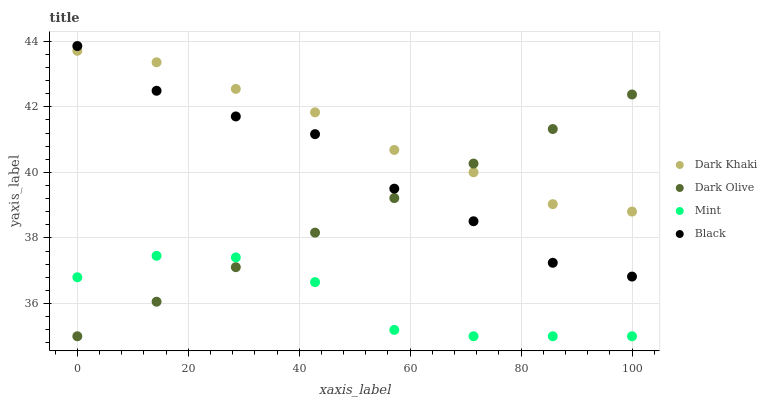Does Mint have the minimum area under the curve?
Answer yes or no. Yes. Does Dark Khaki have the maximum area under the curve?
Answer yes or no. Yes. Does Black have the minimum area under the curve?
Answer yes or no. No. Does Black have the maximum area under the curve?
Answer yes or no. No. Is Dark Olive the smoothest?
Answer yes or no. Yes. Is Black the roughest?
Answer yes or no. Yes. Is Black the smoothest?
Answer yes or no. No. Is Dark Olive the roughest?
Answer yes or no. No. Does Dark Olive have the lowest value?
Answer yes or no. Yes. Does Black have the lowest value?
Answer yes or no. No. Does Black have the highest value?
Answer yes or no. Yes. Does Dark Olive have the highest value?
Answer yes or no. No. Is Mint less than Black?
Answer yes or no. Yes. Is Dark Khaki greater than Mint?
Answer yes or no. Yes. Does Dark Khaki intersect Dark Olive?
Answer yes or no. Yes. Is Dark Khaki less than Dark Olive?
Answer yes or no. No. Is Dark Khaki greater than Dark Olive?
Answer yes or no. No. Does Mint intersect Black?
Answer yes or no. No. 